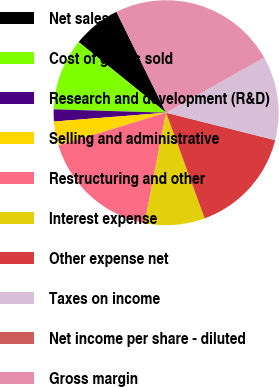Convert chart to OTSL. <chart><loc_0><loc_0><loc_500><loc_500><pie_chart><fcel>Net sales<fcel>Cost of goods sold<fcel>Research and development (R&D)<fcel>Selling and administrative<fcel>Restructuring and other<fcel>Interest expense<fcel>Other expense net<fcel>Taxes on income<fcel>Net income per share - diluted<fcel>Gross margin<nl><fcel>6.9%<fcel>10.34%<fcel>1.73%<fcel>3.45%<fcel>17.24%<fcel>8.62%<fcel>15.51%<fcel>12.07%<fcel>0.01%<fcel>24.13%<nl></chart> 